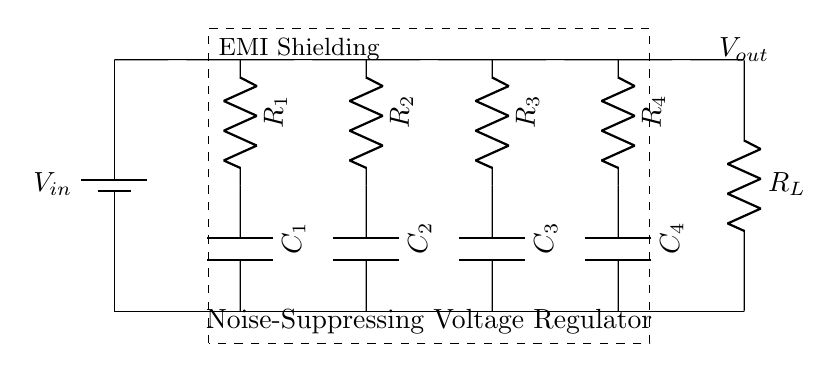What is the input voltage of this circuit? The input voltage, labeled as V_in, is the voltage supplied to the regulator circuit, which is typically provided by a battery or other power source.
Answer: V_in What type of components are used in the circuit? The circuit includes resistors and capacitors, indicated by R and C labels, respectively. These components are essential for filtering and regulating the voltage.
Answer: Resistors and capacitors How many resistors are present in this circuit? The circuit diagram shows four resistors, labeled R1, R2, R3, and R4. Each resistor plays a role in the voltage regulation and noise suppression process.
Answer: Four What does EMI stand for in the context of this circuit? EMI stands for electromagnetic interference, which the circuit is designed to suppress by using various filtering components to ensure clean output for sensitive audio equipment.
Answer: Electromagnetic interference What is the purpose of the capacitors in this circuit? The capacitors are used to smooth the voltage output and filter out noise, helping reduce electromagnetic interference that could affect audio quality.
Answer: Smooth and filter noise What is the output voltage of this circuit referred to as? The output voltage, shown as V_out, is the regulated voltage provided by the circuit to the load after processing the input voltage and suppressing interference.
Answer: V_out What is the significance of labeling the EMI shielding in the circuit? EMI shielding indicates the design focus on minimizing electromagnetic interference, which is critical for protecting sensitive audio equipment in environments like a courtroom.
Answer: Noise suppression 